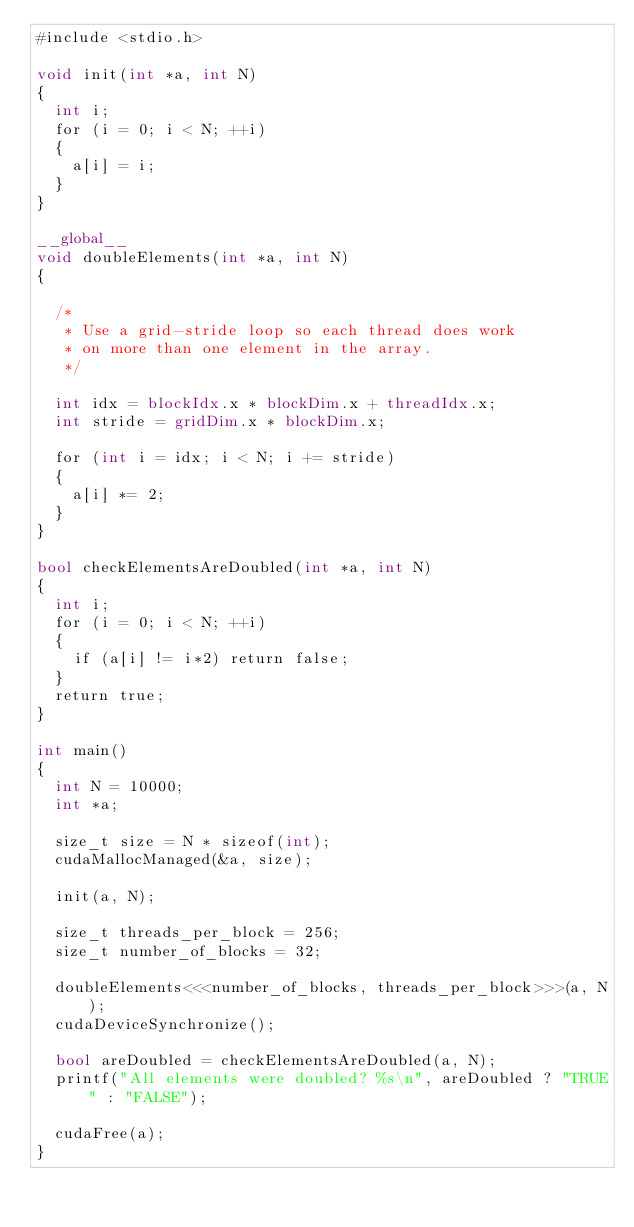Convert code to text. <code><loc_0><loc_0><loc_500><loc_500><_Cuda_>#include <stdio.h>

void init(int *a, int N)
{
  int i;
  for (i = 0; i < N; ++i)
  {
    a[i] = i;
  }
}

__global__
void doubleElements(int *a, int N)
{

  /*
   * Use a grid-stride loop so each thread does work
   * on more than one element in the array.
   */

  int idx = blockIdx.x * blockDim.x + threadIdx.x;
  int stride = gridDim.x * blockDim.x;

  for (int i = idx; i < N; i += stride)
  {
    a[i] *= 2;
  }
}

bool checkElementsAreDoubled(int *a, int N)
{
  int i;
  for (i = 0; i < N; ++i)
  {
    if (a[i] != i*2) return false;
  }
  return true;
}

int main()
{
  int N = 10000;
  int *a;

  size_t size = N * sizeof(int);
  cudaMallocManaged(&a, size);

  init(a, N);

  size_t threads_per_block = 256;
  size_t number_of_blocks = 32;

  doubleElements<<<number_of_blocks, threads_per_block>>>(a, N);
  cudaDeviceSynchronize();

  bool areDoubled = checkElementsAreDoubled(a, N);
  printf("All elements were doubled? %s\n", areDoubled ? "TRUE" : "FALSE");

  cudaFree(a);
}
</code> 